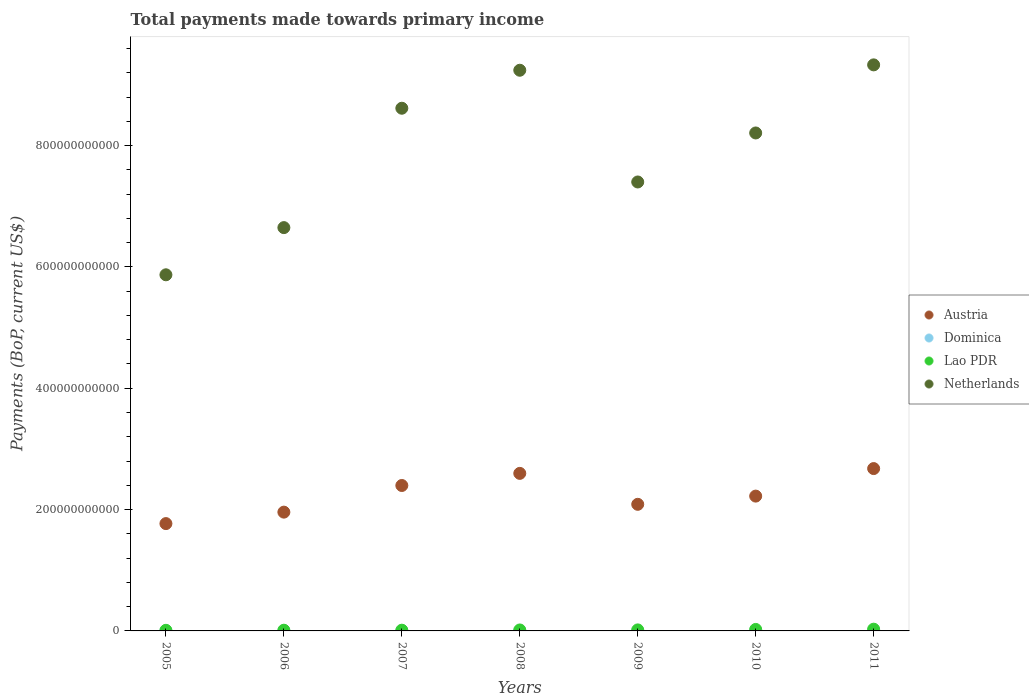How many different coloured dotlines are there?
Offer a very short reply. 4. Is the number of dotlines equal to the number of legend labels?
Make the answer very short. Yes. What is the total payments made towards primary income in Netherlands in 2009?
Your answer should be very brief. 7.40e+11. Across all years, what is the maximum total payments made towards primary income in Netherlands?
Make the answer very short. 9.33e+11. Across all years, what is the minimum total payments made towards primary income in Lao PDR?
Your answer should be very brief. 1.00e+09. In which year was the total payments made towards primary income in Lao PDR maximum?
Your response must be concise. 2011. In which year was the total payments made towards primary income in Lao PDR minimum?
Give a very brief answer. 2005. What is the total total payments made towards primary income in Lao PDR in the graph?
Keep it short and to the point. 1.20e+1. What is the difference between the total payments made towards primary income in Netherlands in 2005 and that in 2008?
Make the answer very short. -3.37e+11. What is the difference between the total payments made towards primary income in Netherlands in 2006 and the total payments made towards primary income in Dominica in 2009?
Your answer should be very brief. 6.65e+11. What is the average total payments made towards primary income in Dominica per year?
Your response must be concise. 2.68e+08. In the year 2011, what is the difference between the total payments made towards primary income in Austria and total payments made towards primary income in Lao PDR?
Keep it short and to the point. 2.65e+11. What is the ratio of the total payments made towards primary income in Dominica in 2009 to that in 2010?
Your answer should be very brief. 1.02. Is the total payments made towards primary income in Dominica in 2008 less than that in 2010?
Offer a very short reply. No. What is the difference between the highest and the second highest total payments made towards primary income in Austria?
Your answer should be very brief. 7.91e+09. What is the difference between the highest and the lowest total payments made towards primary income in Dominica?
Provide a short and direct response. 9.40e+07. Is the sum of the total payments made towards primary income in Lao PDR in 2006 and 2008 greater than the maximum total payments made towards primary income in Netherlands across all years?
Your response must be concise. No. Is it the case that in every year, the sum of the total payments made towards primary income in Netherlands and total payments made towards primary income in Austria  is greater than the sum of total payments made towards primary income in Lao PDR and total payments made towards primary income in Dominica?
Your response must be concise. Yes. Is it the case that in every year, the sum of the total payments made towards primary income in Netherlands and total payments made towards primary income in Austria  is greater than the total payments made towards primary income in Dominica?
Your answer should be very brief. Yes. Does the total payments made towards primary income in Austria monotonically increase over the years?
Your answer should be compact. No. How many dotlines are there?
Provide a short and direct response. 4. How many years are there in the graph?
Your answer should be compact. 7. What is the difference between two consecutive major ticks on the Y-axis?
Make the answer very short. 2.00e+11. Are the values on the major ticks of Y-axis written in scientific E-notation?
Make the answer very short. No. Where does the legend appear in the graph?
Your response must be concise. Center right. What is the title of the graph?
Your answer should be compact. Total payments made towards primary income. What is the label or title of the X-axis?
Offer a very short reply. Years. What is the label or title of the Y-axis?
Give a very brief answer. Payments (BoP, current US$). What is the Payments (BoP, current US$) of Austria in 2005?
Provide a succinct answer. 1.77e+11. What is the Payments (BoP, current US$) in Dominica in 2005?
Keep it short and to the point. 2.31e+08. What is the Payments (BoP, current US$) in Lao PDR in 2005?
Keep it short and to the point. 1.00e+09. What is the Payments (BoP, current US$) of Netherlands in 2005?
Provide a succinct answer. 5.87e+11. What is the Payments (BoP, current US$) of Austria in 2006?
Your answer should be very brief. 1.96e+11. What is the Payments (BoP, current US$) of Dominica in 2006?
Offer a terse response. 2.20e+08. What is the Payments (BoP, current US$) of Lao PDR in 2006?
Ensure brevity in your answer.  1.17e+09. What is the Payments (BoP, current US$) of Netherlands in 2006?
Ensure brevity in your answer.  6.65e+11. What is the Payments (BoP, current US$) of Austria in 2007?
Your answer should be compact. 2.40e+11. What is the Payments (BoP, current US$) in Dominica in 2007?
Your response must be concise. 2.64e+08. What is the Payments (BoP, current US$) in Lao PDR in 2007?
Make the answer very short. 1.20e+09. What is the Payments (BoP, current US$) in Netherlands in 2007?
Provide a short and direct response. 8.62e+11. What is the Payments (BoP, current US$) in Austria in 2008?
Ensure brevity in your answer.  2.60e+11. What is the Payments (BoP, current US$) in Dominica in 2008?
Your answer should be compact. 3.14e+08. What is the Payments (BoP, current US$) in Lao PDR in 2008?
Keep it short and to the point. 1.59e+09. What is the Payments (BoP, current US$) in Netherlands in 2008?
Your answer should be compact. 9.24e+11. What is the Payments (BoP, current US$) in Austria in 2009?
Your response must be concise. 2.09e+11. What is the Payments (BoP, current US$) of Dominica in 2009?
Offer a terse response. 2.85e+08. What is the Payments (BoP, current US$) in Lao PDR in 2009?
Make the answer very short. 1.69e+09. What is the Payments (BoP, current US$) of Netherlands in 2009?
Provide a succinct answer. 7.40e+11. What is the Payments (BoP, current US$) of Austria in 2010?
Make the answer very short. 2.22e+11. What is the Payments (BoP, current US$) in Dominica in 2010?
Offer a very short reply. 2.80e+08. What is the Payments (BoP, current US$) of Lao PDR in 2010?
Your response must be concise. 2.46e+09. What is the Payments (BoP, current US$) in Netherlands in 2010?
Your answer should be compact. 8.21e+11. What is the Payments (BoP, current US$) in Austria in 2011?
Your answer should be very brief. 2.68e+11. What is the Payments (BoP, current US$) of Dominica in 2011?
Make the answer very short. 2.80e+08. What is the Payments (BoP, current US$) in Lao PDR in 2011?
Offer a terse response. 2.88e+09. What is the Payments (BoP, current US$) in Netherlands in 2011?
Your answer should be very brief. 9.33e+11. Across all years, what is the maximum Payments (BoP, current US$) of Austria?
Keep it short and to the point. 2.68e+11. Across all years, what is the maximum Payments (BoP, current US$) of Dominica?
Offer a terse response. 3.14e+08. Across all years, what is the maximum Payments (BoP, current US$) of Lao PDR?
Ensure brevity in your answer.  2.88e+09. Across all years, what is the maximum Payments (BoP, current US$) of Netherlands?
Ensure brevity in your answer.  9.33e+11. Across all years, what is the minimum Payments (BoP, current US$) of Austria?
Give a very brief answer. 1.77e+11. Across all years, what is the minimum Payments (BoP, current US$) in Dominica?
Offer a terse response. 2.20e+08. Across all years, what is the minimum Payments (BoP, current US$) of Lao PDR?
Provide a short and direct response. 1.00e+09. Across all years, what is the minimum Payments (BoP, current US$) of Netherlands?
Offer a terse response. 5.87e+11. What is the total Payments (BoP, current US$) in Austria in the graph?
Give a very brief answer. 1.57e+12. What is the total Payments (BoP, current US$) in Dominica in the graph?
Your answer should be compact. 1.87e+09. What is the total Payments (BoP, current US$) of Lao PDR in the graph?
Give a very brief answer. 1.20e+1. What is the total Payments (BoP, current US$) of Netherlands in the graph?
Ensure brevity in your answer.  5.53e+12. What is the difference between the Payments (BoP, current US$) of Austria in 2005 and that in 2006?
Your answer should be very brief. -1.89e+1. What is the difference between the Payments (BoP, current US$) of Dominica in 2005 and that in 2006?
Ensure brevity in your answer.  1.10e+07. What is the difference between the Payments (BoP, current US$) in Lao PDR in 2005 and that in 2006?
Your response must be concise. -1.70e+08. What is the difference between the Payments (BoP, current US$) of Netherlands in 2005 and that in 2006?
Your answer should be compact. -7.78e+1. What is the difference between the Payments (BoP, current US$) of Austria in 2005 and that in 2007?
Make the answer very short. -6.28e+1. What is the difference between the Payments (BoP, current US$) in Dominica in 2005 and that in 2007?
Make the answer very short. -3.35e+07. What is the difference between the Payments (BoP, current US$) of Lao PDR in 2005 and that in 2007?
Provide a succinct answer. -1.99e+08. What is the difference between the Payments (BoP, current US$) in Netherlands in 2005 and that in 2007?
Provide a short and direct response. -2.75e+11. What is the difference between the Payments (BoP, current US$) in Austria in 2005 and that in 2008?
Offer a very short reply. -8.28e+1. What is the difference between the Payments (BoP, current US$) in Dominica in 2005 and that in 2008?
Your response must be concise. -8.30e+07. What is the difference between the Payments (BoP, current US$) in Lao PDR in 2005 and that in 2008?
Offer a terse response. -5.85e+08. What is the difference between the Payments (BoP, current US$) of Netherlands in 2005 and that in 2008?
Provide a succinct answer. -3.37e+11. What is the difference between the Payments (BoP, current US$) in Austria in 2005 and that in 2009?
Your answer should be very brief. -3.18e+1. What is the difference between the Payments (BoP, current US$) in Dominica in 2005 and that in 2009?
Offer a terse response. -5.37e+07. What is the difference between the Payments (BoP, current US$) in Lao PDR in 2005 and that in 2009?
Offer a very short reply. -6.82e+08. What is the difference between the Payments (BoP, current US$) of Netherlands in 2005 and that in 2009?
Ensure brevity in your answer.  -1.53e+11. What is the difference between the Payments (BoP, current US$) of Austria in 2005 and that in 2010?
Make the answer very short. -4.53e+1. What is the difference between the Payments (BoP, current US$) in Dominica in 2005 and that in 2010?
Ensure brevity in your answer.  -4.90e+07. What is the difference between the Payments (BoP, current US$) in Lao PDR in 2005 and that in 2010?
Your answer should be compact. -1.45e+09. What is the difference between the Payments (BoP, current US$) in Netherlands in 2005 and that in 2010?
Ensure brevity in your answer.  -2.34e+11. What is the difference between the Payments (BoP, current US$) in Austria in 2005 and that in 2011?
Provide a short and direct response. -9.07e+1. What is the difference between the Payments (BoP, current US$) in Dominica in 2005 and that in 2011?
Ensure brevity in your answer.  -4.93e+07. What is the difference between the Payments (BoP, current US$) in Lao PDR in 2005 and that in 2011?
Make the answer very short. -1.88e+09. What is the difference between the Payments (BoP, current US$) in Netherlands in 2005 and that in 2011?
Your response must be concise. -3.46e+11. What is the difference between the Payments (BoP, current US$) in Austria in 2006 and that in 2007?
Your answer should be very brief. -4.39e+1. What is the difference between the Payments (BoP, current US$) in Dominica in 2006 and that in 2007?
Give a very brief answer. -4.45e+07. What is the difference between the Payments (BoP, current US$) in Lao PDR in 2006 and that in 2007?
Provide a succinct answer. -2.94e+07. What is the difference between the Payments (BoP, current US$) of Netherlands in 2006 and that in 2007?
Provide a succinct answer. -1.97e+11. What is the difference between the Payments (BoP, current US$) in Austria in 2006 and that in 2008?
Offer a terse response. -6.39e+1. What is the difference between the Payments (BoP, current US$) in Dominica in 2006 and that in 2008?
Offer a terse response. -9.40e+07. What is the difference between the Payments (BoP, current US$) of Lao PDR in 2006 and that in 2008?
Offer a terse response. -4.16e+08. What is the difference between the Payments (BoP, current US$) in Netherlands in 2006 and that in 2008?
Offer a terse response. -2.59e+11. What is the difference between the Payments (BoP, current US$) of Austria in 2006 and that in 2009?
Your answer should be very brief. -1.29e+1. What is the difference between the Payments (BoP, current US$) of Dominica in 2006 and that in 2009?
Give a very brief answer. -6.47e+07. What is the difference between the Payments (BoP, current US$) of Lao PDR in 2006 and that in 2009?
Provide a short and direct response. -5.12e+08. What is the difference between the Payments (BoP, current US$) of Netherlands in 2006 and that in 2009?
Ensure brevity in your answer.  -7.52e+1. What is the difference between the Payments (BoP, current US$) in Austria in 2006 and that in 2010?
Offer a terse response. -2.64e+1. What is the difference between the Payments (BoP, current US$) in Dominica in 2006 and that in 2010?
Ensure brevity in your answer.  -6.00e+07. What is the difference between the Payments (BoP, current US$) of Lao PDR in 2006 and that in 2010?
Offer a very short reply. -1.28e+09. What is the difference between the Payments (BoP, current US$) in Netherlands in 2006 and that in 2010?
Ensure brevity in your answer.  -1.56e+11. What is the difference between the Payments (BoP, current US$) of Austria in 2006 and that in 2011?
Keep it short and to the point. -7.18e+1. What is the difference between the Payments (BoP, current US$) in Dominica in 2006 and that in 2011?
Offer a terse response. -6.03e+07. What is the difference between the Payments (BoP, current US$) in Lao PDR in 2006 and that in 2011?
Make the answer very short. -1.71e+09. What is the difference between the Payments (BoP, current US$) of Netherlands in 2006 and that in 2011?
Provide a short and direct response. -2.68e+11. What is the difference between the Payments (BoP, current US$) of Austria in 2007 and that in 2008?
Your answer should be very brief. -2.00e+1. What is the difference between the Payments (BoP, current US$) of Dominica in 2007 and that in 2008?
Keep it short and to the point. -4.96e+07. What is the difference between the Payments (BoP, current US$) in Lao PDR in 2007 and that in 2008?
Make the answer very short. -3.86e+08. What is the difference between the Payments (BoP, current US$) of Netherlands in 2007 and that in 2008?
Make the answer very short. -6.26e+1. What is the difference between the Payments (BoP, current US$) in Austria in 2007 and that in 2009?
Your answer should be compact. 3.10e+1. What is the difference between the Payments (BoP, current US$) of Dominica in 2007 and that in 2009?
Keep it short and to the point. -2.02e+07. What is the difference between the Payments (BoP, current US$) in Lao PDR in 2007 and that in 2009?
Your answer should be very brief. -4.83e+08. What is the difference between the Payments (BoP, current US$) of Netherlands in 2007 and that in 2009?
Provide a succinct answer. 1.22e+11. What is the difference between the Payments (BoP, current US$) of Austria in 2007 and that in 2010?
Your response must be concise. 1.75e+1. What is the difference between the Payments (BoP, current US$) in Dominica in 2007 and that in 2010?
Give a very brief answer. -1.56e+07. What is the difference between the Payments (BoP, current US$) in Lao PDR in 2007 and that in 2010?
Your answer should be very brief. -1.25e+09. What is the difference between the Payments (BoP, current US$) of Netherlands in 2007 and that in 2010?
Make the answer very short. 4.08e+1. What is the difference between the Payments (BoP, current US$) in Austria in 2007 and that in 2011?
Your answer should be compact. -2.79e+1. What is the difference between the Payments (BoP, current US$) in Dominica in 2007 and that in 2011?
Offer a terse response. -1.58e+07. What is the difference between the Payments (BoP, current US$) of Lao PDR in 2007 and that in 2011?
Ensure brevity in your answer.  -1.68e+09. What is the difference between the Payments (BoP, current US$) in Netherlands in 2007 and that in 2011?
Your answer should be compact. -7.15e+1. What is the difference between the Payments (BoP, current US$) of Austria in 2008 and that in 2009?
Provide a short and direct response. 5.10e+1. What is the difference between the Payments (BoP, current US$) of Dominica in 2008 and that in 2009?
Make the answer very short. 2.94e+07. What is the difference between the Payments (BoP, current US$) of Lao PDR in 2008 and that in 2009?
Provide a short and direct response. -9.67e+07. What is the difference between the Payments (BoP, current US$) in Netherlands in 2008 and that in 2009?
Provide a short and direct response. 1.84e+11. What is the difference between the Payments (BoP, current US$) of Austria in 2008 and that in 2010?
Ensure brevity in your answer.  3.75e+1. What is the difference between the Payments (BoP, current US$) in Dominica in 2008 and that in 2010?
Ensure brevity in your answer.  3.40e+07. What is the difference between the Payments (BoP, current US$) in Lao PDR in 2008 and that in 2010?
Your response must be concise. -8.68e+08. What is the difference between the Payments (BoP, current US$) of Netherlands in 2008 and that in 2010?
Your answer should be very brief. 1.03e+11. What is the difference between the Payments (BoP, current US$) of Austria in 2008 and that in 2011?
Your answer should be compact. -7.91e+09. What is the difference between the Payments (BoP, current US$) of Dominica in 2008 and that in 2011?
Offer a very short reply. 3.38e+07. What is the difference between the Payments (BoP, current US$) of Lao PDR in 2008 and that in 2011?
Your answer should be compact. -1.29e+09. What is the difference between the Payments (BoP, current US$) in Netherlands in 2008 and that in 2011?
Your answer should be very brief. -8.86e+09. What is the difference between the Payments (BoP, current US$) of Austria in 2009 and that in 2010?
Ensure brevity in your answer.  -1.35e+1. What is the difference between the Payments (BoP, current US$) of Dominica in 2009 and that in 2010?
Offer a terse response. 4.64e+06. What is the difference between the Payments (BoP, current US$) of Lao PDR in 2009 and that in 2010?
Offer a very short reply. -7.72e+08. What is the difference between the Payments (BoP, current US$) in Netherlands in 2009 and that in 2010?
Ensure brevity in your answer.  -8.08e+1. What is the difference between the Payments (BoP, current US$) in Austria in 2009 and that in 2011?
Provide a succinct answer. -5.89e+1. What is the difference between the Payments (BoP, current US$) of Dominica in 2009 and that in 2011?
Provide a short and direct response. 4.40e+06. What is the difference between the Payments (BoP, current US$) in Lao PDR in 2009 and that in 2011?
Your response must be concise. -1.20e+09. What is the difference between the Payments (BoP, current US$) of Netherlands in 2009 and that in 2011?
Offer a very short reply. -1.93e+11. What is the difference between the Payments (BoP, current US$) in Austria in 2010 and that in 2011?
Offer a very short reply. -4.54e+1. What is the difference between the Payments (BoP, current US$) in Dominica in 2010 and that in 2011?
Your response must be concise. -2.36e+05. What is the difference between the Payments (BoP, current US$) in Lao PDR in 2010 and that in 2011?
Offer a very short reply. -4.24e+08. What is the difference between the Payments (BoP, current US$) of Netherlands in 2010 and that in 2011?
Ensure brevity in your answer.  -1.12e+11. What is the difference between the Payments (BoP, current US$) in Austria in 2005 and the Payments (BoP, current US$) in Dominica in 2006?
Keep it short and to the point. 1.77e+11. What is the difference between the Payments (BoP, current US$) of Austria in 2005 and the Payments (BoP, current US$) of Lao PDR in 2006?
Offer a terse response. 1.76e+11. What is the difference between the Payments (BoP, current US$) of Austria in 2005 and the Payments (BoP, current US$) of Netherlands in 2006?
Offer a terse response. -4.88e+11. What is the difference between the Payments (BoP, current US$) in Dominica in 2005 and the Payments (BoP, current US$) in Lao PDR in 2006?
Your answer should be compact. -9.42e+08. What is the difference between the Payments (BoP, current US$) in Dominica in 2005 and the Payments (BoP, current US$) in Netherlands in 2006?
Offer a terse response. -6.65e+11. What is the difference between the Payments (BoP, current US$) of Lao PDR in 2005 and the Payments (BoP, current US$) of Netherlands in 2006?
Ensure brevity in your answer.  -6.64e+11. What is the difference between the Payments (BoP, current US$) of Austria in 2005 and the Payments (BoP, current US$) of Dominica in 2007?
Provide a short and direct response. 1.77e+11. What is the difference between the Payments (BoP, current US$) of Austria in 2005 and the Payments (BoP, current US$) of Lao PDR in 2007?
Make the answer very short. 1.76e+11. What is the difference between the Payments (BoP, current US$) of Austria in 2005 and the Payments (BoP, current US$) of Netherlands in 2007?
Your answer should be very brief. -6.85e+11. What is the difference between the Payments (BoP, current US$) of Dominica in 2005 and the Payments (BoP, current US$) of Lao PDR in 2007?
Your answer should be compact. -9.71e+08. What is the difference between the Payments (BoP, current US$) in Dominica in 2005 and the Payments (BoP, current US$) in Netherlands in 2007?
Keep it short and to the point. -8.61e+11. What is the difference between the Payments (BoP, current US$) of Lao PDR in 2005 and the Payments (BoP, current US$) of Netherlands in 2007?
Provide a short and direct response. -8.61e+11. What is the difference between the Payments (BoP, current US$) in Austria in 2005 and the Payments (BoP, current US$) in Dominica in 2008?
Your answer should be very brief. 1.77e+11. What is the difference between the Payments (BoP, current US$) of Austria in 2005 and the Payments (BoP, current US$) of Lao PDR in 2008?
Your response must be concise. 1.75e+11. What is the difference between the Payments (BoP, current US$) of Austria in 2005 and the Payments (BoP, current US$) of Netherlands in 2008?
Offer a very short reply. -7.47e+11. What is the difference between the Payments (BoP, current US$) of Dominica in 2005 and the Payments (BoP, current US$) of Lao PDR in 2008?
Provide a succinct answer. -1.36e+09. What is the difference between the Payments (BoP, current US$) in Dominica in 2005 and the Payments (BoP, current US$) in Netherlands in 2008?
Your answer should be very brief. -9.24e+11. What is the difference between the Payments (BoP, current US$) in Lao PDR in 2005 and the Payments (BoP, current US$) in Netherlands in 2008?
Ensure brevity in your answer.  -9.23e+11. What is the difference between the Payments (BoP, current US$) in Austria in 2005 and the Payments (BoP, current US$) in Dominica in 2009?
Offer a very short reply. 1.77e+11. What is the difference between the Payments (BoP, current US$) of Austria in 2005 and the Payments (BoP, current US$) of Lao PDR in 2009?
Offer a very short reply. 1.75e+11. What is the difference between the Payments (BoP, current US$) in Austria in 2005 and the Payments (BoP, current US$) in Netherlands in 2009?
Keep it short and to the point. -5.63e+11. What is the difference between the Payments (BoP, current US$) in Dominica in 2005 and the Payments (BoP, current US$) in Lao PDR in 2009?
Offer a very short reply. -1.45e+09. What is the difference between the Payments (BoP, current US$) of Dominica in 2005 and the Payments (BoP, current US$) of Netherlands in 2009?
Your answer should be compact. -7.40e+11. What is the difference between the Payments (BoP, current US$) of Lao PDR in 2005 and the Payments (BoP, current US$) of Netherlands in 2009?
Your answer should be very brief. -7.39e+11. What is the difference between the Payments (BoP, current US$) in Austria in 2005 and the Payments (BoP, current US$) in Dominica in 2010?
Keep it short and to the point. 1.77e+11. What is the difference between the Payments (BoP, current US$) in Austria in 2005 and the Payments (BoP, current US$) in Lao PDR in 2010?
Offer a very short reply. 1.74e+11. What is the difference between the Payments (BoP, current US$) in Austria in 2005 and the Payments (BoP, current US$) in Netherlands in 2010?
Ensure brevity in your answer.  -6.44e+11. What is the difference between the Payments (BoP, current US$) in Dominica in 2005 and the Payments (BoP, current US$) in Lao PDR in 2010?
Your answer should be compact. -2.23e+09. What is the difference between the Payments (BoP, current US$) in Dominica in 2005 and the Payments (BoP, current US$) in Netherlands in 2010?
Provide a succinct answer. -8.21e+11. What is the difference between the Payments (BoP, current US$) of Lao PDR in 2005 and the Payments (BoP, current US$) of Netherlands in 2010?
Make the answer very short. -8.20e+11. What is the difference between the Payments (BoP, current US$) in Austria in 2005 and the Payments (BoP, current US$) in Dominica in 2011?
Your answer should be compact. 1.77e+11. What is the difference between the Payments (BoP, current US$) of Austria in 2005 and the Payments (BoP, current US$) of Lao PDR in 2011?
Your answer should be compact. 1.74e+11. What is the difference between the Payments (BoP, current US$) in Austria in 2005 and the Payments (BoP, current US$) in Netherlands in 2011?
Provide a succinct answer. -7.56e+11. What is the difference between the Payments (BoP, current US$) in Dominica in 2005 and the Payments (BoP, current US$) in Lao PDR in 2011?
Offer a very short reply. -2.65e+09. What is the difference between the Payments (BoP, current US$) of Dominica in 2005 and the Payments (BoP, current US$) of Netherlands in 2011?
Offer a terse response. -9.33e+11. What is the difference between the Payments (BoP, current US$) of Lao PDR in 2005 and the Payments (BoP, current US$) of Netherlands in 2011?
Your response must be concise. -9.32e+11. What is the difference between the Payments (BoP, current US$) of Austria in 2006 and the Payments (BoP, current US$) of Dominica in 2007?
Provide a short and direct response. 1.96e+11. What is the difference between the Payments (BoP, current US$) of Austria in 2006 and the Payments (BoP, current US$) of Lao PDR in 2007?
Provide a succinct answer. 1.95e+11. What is the difference between the Payments (BoP, current US$) in Austria in 2006 and the Payments (BoP, current US$) in Netherlands in 2007?
Your response must be concise. -6.66e+11. What is the difference between the Payments (BoP, current US$) in Dominica in 2006 and the Payments (BoP, current US$) in Lao PDR in 2007?
Ensure brevity in your answer.  -9.82e+08. What is the difference between the Payments (BoP, current US$) in Dominica in 2006 and the Payments (BoP, current US$) in Netherlands in 2007?
Your answer should be compact. -8.61e+11. What is the difference between the Payments (BoP, current US$) in Lao PDR in 2006 and the Payments (BoP, current US$) in Netherlands in 2007?
Give a very brief answer. -8.60e+11. What is the difference between the Payments (BoP, current US$) of Austria in 2006 and the Payments (BoP, current US$) of Dominica in 2008?
Your answer should be compact. 1.95e+11. What is the difference between the Payments (BoP, current US$) of Austria in 2006 and the Payments (BoP, current US$) of Lao PDR in 2008?
Your answer should be very brief. 1.94e+11. What is the difference between the Payments (BoP, current US$) in Austria in 2006 and the Payments (BoP, current US$) in Netherlands in 2008?
Your answer should be very brief. -7.28e+11. What is the difference between the Payments (BoP, current US$) in Dominica in 2006 and the Payments (BoP, current US$) in Lao PDR in 2008?
Provide a succinct answer. -1.37e+09. What is the difference between the Payments (BoP, current US$) of Dominica in 2006 and the Payments (BoP, current US$) of Netherlands in 2008?
Your response must be concise. -9.24e+11. What is the difference between the Payments (BoP, current US$) in Lao PDR in 2006 and the Payments (BoP, current US$) in Netherlands in 2008?
Provide a succinct answer. -9.23e+11. What is the difference between the Payments (BoP, current US$) in Austria in 2006 and the Payments (BoP, current US$) in Dominica in 2009?
Make the answer very short. 1.96e+11. What is the difference between the Payments (BoP, current US$) of Austria in 2006 and the Payments (BoP, current US$) of Lao PDR in 2009?
Keep it short and to the point. 1.94e+11. What is the difference between the Payments (BoP, current US$) in Austria in 2006 and the Payments (BoP, current US$) in Netherlands in 2009?
Ensure brevity in your answer.  -5.44e+11. What is the difference between the Payments (BoP, current US$) of Dominica in 2006 and the Payments (BoP, current US$) of Lao PDR in 2009?
Make the answer very short. -1.47e+09. What is the difference between the Payments (BoP, current US$) in Dominica in 2006 and the Payments (BoP, current US$) in Netherlands in 2009?
Your answer should be very brief. -7.40e+11. What is the difference between the Payments (BoP, current US$) in Lao PDR in 2006 and the Payments (BoP, current US$) in Netherlands in 2009?
Your response must be concise. -7.39e+11. What is the difference between the Payments (BoP, current US$) of Austria in 2006 and the Payments (BoP, current US$) of Dominica in 2010?
Offer a very short reply. 1.96e+11. What is the difference between the Payments (BoP, current US$) in Austria in 2006 and the Payments (BoP, current US$) in Lao PDR in 2010?
Provide a succinct answer. 1.93e+11. What is the difference between the Payments (BoP, current US$) in Austria in 2006 and the Payments (BoP, current US$) in Netherlands in 2010?
Offer a very short reply. -6.25e+11. What is the difference between the Payments (BoP, current US$) of Dominica in 2006 and the Payments (BoP, current US$) of Lao PDR in 2010?
Ensure brevity in your answer.  -2.24e+09. What is the difference between the Payments (BoP, current US$) of Dominica in 2006 and the Payments (BoP, current US$) of Netherlands in 2010?
Offer a very short reply. -8.21e+11. What is the difference between the Payments (BoP, current US$) in Lao PDR in 2006 and the Payments (BoP, current US$) in Netherlands in 2010?
Your answer should be compact. -8.20e+11. What is the difference between the Payments (BoP, current US$) of Austria in 2006 and the Payments (BoP, current US$) of Dominica in 2011?
Give a very brief answer. 1.96e+11. What is the difference between the Payments (BoP, current US$) of Austria in 2006 and the Payments (BoP, current US$) of Lao PDR in 2011?
Keep it short and to the point. 1.93e+11. What is the difference between the Payments (BoP, current US$) in Austria in 2006 and the Payments (BoP, current US$) in Netherlands in 2011?
Give a very brief answer. -7.37e+11. What is the difference between the Payments (BoP, current US$) in Dominica in 2006 and the Payments (BoP, current US$) in Lao PDR in 2011?
Make the answer very short. -2.66e+09. What is the difference between the Payments (BoP, current US$) in Dominica in 2006 and the Payments (BoP, current US$) in Netherlands in 2011?
Your response must be concise. -9.33e+11. What is the difference between the Payments (BoP, current US$) in Lao PDR in 2006 and the Payments (BoP, current US$) in Netherlands in 2011?
Give a very brief answer. -9.32e+11. What is the difference between the Payments (BoP, current US$) of Austria in 2007 and the Payments (BoP, current US$) of Dominica in 2008?
Provide a short and direct response. 2.39e+11. What is the difference between the Payments (BoP, current US$) of Austria in 2007 and the Payments (BoP, current US$) of Lao PDR in 2008?
Provide a succinct answer. 2.38e+11. What is the difference between the Payments (BoP, current US$) of Austria in 2007 and the Payments (BoP, current US$) of Netherlands in 2008?
Provide a short and direct response. -6.84e+11. What is the difference between the Payments (BoP, current US$) in Dominica in 2007 and the Payments (BoP, current US$) in Lao PDR in 2008?
Ensure brevity in your answer.  -1.32e+09. What is the difference between the Payments (BoP, current US$) in Dominica in 2007 and the Payments (BoP, current US$) in Netherlands in 2008?
Your answer should be very brief. -9.24e+11. What is the difference between the Payments (BoP, current US$) of Lao PDR in 2007 and the Payments (BoP, current US$) of Netherlands in 2008?
Offer a very short reply. -9.23e+11. What is the difference between the Payments (BoP, current US$) in Austria in 2007 and the Payments (BoP, current US$) in Dominica in 2009?
Keep it short and to the point. 2.39e+11. What is the difference between the Payments (BoP, current US$) in Austria in 2007 and the Payments (BoP, current US$) in Lao PDR in 2009?
Keep it short and to the point. 2.38e+11. What is the difference between the Payments (BoP, current US$) of Austria in 2007 and the Payments (BoP, current US$) of Netherlands in 2009?
Your answer should be compact. -5.00e+11. What is the difference between the Payments (BoP, current US$) in Dominica in 2007 and the Payments (BoP, current US$) in Lao PDR in 2009?
Ensure brevity in your answer.  -1.42e+09. What is the difference between the Payments (BoP, current US$) in Dominica in 2007 and the Payments (BoP, current US$) in Netherlands in 2009?
Provide a short and direct response. -7.40e+11. What is the difference between the Payments (BoP, current US$) in Lao PDR in 2007 and the Payments (BoP, current US$) in Netherlands in 2009?
Offer a very short reply. -7.39e+11. What is the difference between the Payments (BoP, current US$) in Austria in 2007 and the Payments (BoP, current US$) in Dominica in 2010?
Give a very brief answer. 2.39e+11. What is the difference between the Payments (BoP, current US$) of Austria in 2007 and the Payments (BoP, current US$) of Lao PDR in 2010?
Provide a short and direct response. 2.37e+11. What is the difference between the Payments (BoP, current US$) of Austria in 2007 and the Payments (BoP, current US$) of Netherlands in 2010?
Keep it short and to the point. -5.81e+11. What is the difference between the Payments (BoP, current US$) in Dominica in 2007 and the Payments (BoP, current US$) in Lao PDR in 2010?
Your response must be concise. -2.19e+09. What is the difference between the Payments (BoP, current US$) of Dominica in 2007 and the Payments (BoP, current US$) of Netherlands in 2010?
Give a very brief answer. -8.21e+11. What is the difference between the Payments (BoP, current US$) of Lao PDR in 2007 and the Payments (BoP, current US$) of Netherlands in 2010?
Provide a short and direct response. -8.20e+11. What is the difference between the Payments (BoP, current US$) of Austria in 2007 and the Payments (BoP, current US$) of Dominica in 2011?
Offer a very short reply. 2.39e+11. What is the difference between the Payments (BoP, current US$) in Austria in 2007 and the Payments (BoP, current US$) in Lao PDR in 2011?
Your answer should be very brief. 2.37e+11. What is the difference between the Payments (BoP, current US$) of Austria in 2007 and the Payments (BoP, current US$) of Netherlands in 2011?
Make the answer very short. -6.93e+11. What is the difference between the Payments (BoP, current US$) in Dominica in 2007 and the Payments (BoP, current US$) in Lao PDR in 2011?
Ensure brevity in your answer.  -2.62e+09. What is the difference between the Payments (BoP, current US$) in Dominica in 2007 and the Payments (BoP, current US$) in Netherlands in 2011?
Offer a terse response. -9.33e+11. What is the difference between the Payments (BoP, current US$) in Lao PDR in 2007 and the Payments (BoP, current US$) in Netherlands in 2011?
Your response must be concise. -9.32e+11. What is the difference between the Payments (BoP, current US$) in Austria in 2008 and the Payments (BoP, current US$) in Dominica in 2009?
Provide a short and direct response. 2.59e+11. What is the difference between the Payments (BoP, current US$) in Austria in 2008 and the Payments (BoP, current US$) in Lao PDR in 2009?
Keep it short and to the point. 2.58e+11. What is the difference between the Payments (BoP, current US$) in Austria in 2008 and the Payments (BoP, current US$) in Netherlands in 2009?
Give a very brief answer. -4.80e+11. What is the difference between the Payments (BoP, current US$) in Dominica in 2008 and the Payments (BoP, current US$) in Lao PDR in 2009?
Your answer should be very brief. -1.37e+09. What is the difference between the Payments (BoP, current US$) in Dominica in 2008 and the Payments (BoP, current US$) in Netherlands in 2009?
Offer a terse response. -7.40e+11. What is the difference between the Payments (BoP, current US$) of Lao PDR in 2008 and the Payments (BoP, current US$) of Netherlands in 2009?
Make the answer very short. -7.38e+11. What is the difference between the Payments (BoP, current US$) in Austria in 2008 and the Payments (BoP, current US$) in Dominica in 2010?
Provide a short and direct response. 2.59e+11. What is the difference between the Payments (BoP, current US$) in Austria in 2008 and the Payments (BoP, current US$) in Lao PDR in 2010?
Your answer should be very brief. 2.57e+11. What is the difference between the Payments (BoP, current US$) of Austria in 2008 and the Payments (BoP, current US$) of Netherlands in 2010?
Ensure brevity in your answer.  -5.61e+11. What is the difference between the Payments (BoP, current US$) in Dominica in 2008 and the Payments (BoP, current US$) in Lao PDR in 2010?
Give a very brief answer. -2.14e+09. What is the difference between the Payments (BoP, current US$) of Dominica in 2008 and the Payments (BoP, current US$) of Netherlands in 2010?
Provide a succinct answer. -8.20e+11. What is the difference between the Payments (BoP, current US$) in Lao PDR in 2008 and the Payments (BoP, current US$) in Netherlands in 2010?
Your answer should be compact. -8.19e+11. What is the difference between the Payments (BoP, current US$) of Austria in 2008 and the Payments (BoP, current US$) of Dominica in 2011?
Keep it short and to the point. 2.59e+11. What is the difference between the Payments (BoP, current US$) of Austria in 2008 and the Payments (BoP, current US$) of Lao PDR in 2011?
Keep it short and to the point. 2.57e+11. What is the difference between the Payments (BoP, current US$) in Austria in 2008 and the Payments (BoP, current US$) in Netherlands in 2011?
Offer a very short reply. -6.73e+11. What is the difference between the Payments (BoP, current US$) in Dominica in 2008 and the Payments (BoP, current US$) in Lao PDR in 2011?
Your answer should be very brief. -2.57e+09. What is the difference between the Payments (BoP, current US$) of Dominica in 2008 and the Payments (BoP, current US$) of Netherlands in 2011?
Offer a terse response. -9.33e+11. What is the difference between the Payments (BoP, current US$) of Lao PDR in 2008 and the Payments (BoP, current US$) of Netherlands in 2011?
Make the answer very short. -9.31e+11. What is the difference between the Payments (BoP, current US$) in Austria in 2009 and the Payments (BoP, current US$) in Dominica in 2010?
Offer a terse response. 2.08e+11. What is the difference between the Payments (BoP, current US$) in Austria in 2009 and the Payments (BoP, current US$) in Lao PDR in 2010?
Keep it short and to the point. 2.06e+11. What is the difference between the Payments (BoP, current US$) of Austria in 2009 and the Payments (BoP, current US$) of Netherlands in 2010?
Offer a terse response. -6.12e+11. What is the difference between the Payments (BoP, current US$) of Dominica in 2009 and the Payments (BoP, current US$) of Lao PDR in 2010?
Provide a short and direct response. -2.17e+09. What is the difference between the Payments (BoP, current US$) in Dominica in 2009 and the Payments (BoP, current US$) in Netherlands in 2010?
Give a very brief answer. -8.21e+11. What is the difference between the Payments (BoP, current US$) of Lao PDR in 2009 and the Payments (BoP, current US$) of Netherlands in 2010?
Offer a very short reply. -8.19e+11. What is the difference between the Payments (BoP, current US$) of Austria in 2009 and the Payments (BoP, current US$) of Dominica in 2011?
Your answer should be compact. 2.08e+11. What is the difference between the Payments (BoP, current US$) of Austria in 2009 and the Payments (BoP, current US$) of Lao PDR in 2011?
Offer a terse response. 2.06e+11. What is the difference between the Payments (BoP, current US$) of Austria in 2009 and the Payments (BoP, current US$) of Netherlands in 2011?
Your answer should be very brief. -7.24e+11. What is the difference between the Payments (BoP, current US$) in Dominica in 2009 and the Payments (BoP, current US$) in Lao PDR in 2011?
Your response must be concise. -2.60e+09. What is the difference between the Payments (BoP, current US$) in Dominica in 2009 and the Payments (BoP, current US$) in Netherlands in 2011?
Offer a terse response. -9.33e+11. What is the difference between the Payments (BoP, current US$) of Lao PDR in 2009 and the Payments (BoP, current US$) of Netherlands in 2011?
Ensure brevity in your answer.  -9.31e+11. What is the difference between the Payments (BoP, current US$) of Austria in 2010 and the Payments (BoP, current US$) of Dominica in 2011?
Provide a succinct answer. 2.22e+11. What is the difference between the Payments (BoP, current US$) of Austria in 2010 and the Payments (BoP, current US$) of Lao PDR in 2011?
Provide a short and direct response. 2.19e+11. What is the difference between the Payments (BoP, current US$) in Austria in 2010 and the Payments (BoP, current US$) in Netherlands in 2011?
Your response must be concise. -7.11e+11. What is the difference between the Payments (BoP, current US$) in Dominica in 2010 and the Payments (BoP, current US$) in Lao PDR in 2011?
Give a very brief answer. -2.60e+09. What is the difference between the Payments (BoP, current US$) of Dominica in 2010 and the Payments (BoP, current US$) of Netherlands in 2011?
Your answer should be very brief. -9.33e+11. What is the difference between the Payments (BoP, current US$) of Lao PDR in 2010 and the Payments (BoP, current US$) of Netherlands in 2011?
Offer a terse response. -9.31e+11. What is the average Payments (BoP, current US$) of Austria per year?
Provide a succinct answer. 2.24e+11. What is the average Payments (BoP, current US$) in Dominica per year?
Make the answer very short. 2.68e+08. What is the average Payments (BoP, current US$) of Lao PDR per year?
Keep it short and to the point. 1.71e+09. What is the average Payments (BoP, current US$) in Netherlands per year?
Your answer should be compact. 7.90e+11. In the year 2005, what is the difference between the Payments (BoP, current US$) in Austria and Payments (BoP, current US$) in Dominica?
Give a very brief answer. 1.77e+11. In the year 2005, what is the difference between the Payments (BoP, current US$) of Austria and Payments (BoP, current US$) of Lao PDR?
Offer a very short reply. 1.76e+11. In the year 2005, what is the difference between the Payments (BoP, current US$) of Austria and Payments (BoP, current US$) of Netherlands?
Your response must be concise. -4.10e+11. In the year 2005, what is the difference between the Payments (BoP, current US$) in Dominica and Payments (BoP, current US$) in Lao PDR?
Your response must be concise. -7.72e+08. In the year 2005, what is the difference between the Payments (BoP, current US$) of Dominica and Payments (BoP, current US$) of Netherlands?
Your response must be concise. -5.87e+11. In the year 2005, what is the difference between the Payments (BoP, current US$) of Lao PDR and Payments (BoP, current US$) of Netherlands?
Keep it short and to the point. -5.86e+11. In the year 2006, what is the difference between the Payments (BoP, current US$) of Austria and Payments (BoP, current US$) of Dominica?
Ensure brevity in your answer.  1.96e+11. In the year 2006, what is the difference between the Payments (BoP, current US$) in Austria and Payments (BoP, current US$) in Lao PDR?
Keep it short and to the point. 1.95e+11. In the year 2006, what is the difference between the Payments (BoP, current US$) in Austria and Payments (BoP, current US$) in Netherlands?
Ensure brevity in your answer.  -4.69e+11. In the year 2006, what is the difference between the Payments (BoP, current US$) of Dominica and Payments (BoP, current US$) of Lao PDR?
Provide a short and direct response. -9.53e+08. In the year 2006, what is the difference between the Payments (BoP, current US$) of Dominica and Payments (BoP, current US$) of Netherlands?
Your response must be concise. -6.65e+11. In the year 2006, what is the difference between the Payments (BoP, current US$) of Lao PDR and Payments (BoP, current US$) of Netherlands?
Your response must be concise. -6.64e+11. In the year 2007, what is the difference between the Payments (BoP, current US$) in Austria and Payments (BoP, current US$) in Dominica?
Your answer should be very brief. 2.39e+11. In the year 2007, what is the difference between the Payments (BoP, current US$) of Austria and Payments (BoP, current US$) of Lao PDR?
Your answer should be very brief. 2.39e+11. In the year 2007, what is the difference between the Payments (BoP, current US$) of Austria and Payments (BoP, current US$) of Netherlands?
Offer a very short reply. -6.22e+11. In the year 2007, what is the difference between the Payments (BoP, current US$) of Dominica and Payments (BoP, current US$) of Lao PDR?
Provide a succinct answer. -9.38e+08. In the year 2007, what is the difference between the Payments (BoP, current US$) of Dominica and Payments (BoP, current US$) of Netherlands?
Give a very brief answer. -8.61e+11. In the year 2007, what is the difference between the Payments (BoP, current US$) of Lao PDR and Payments (BoP, current US$) of Netherlands?
Offer a very short reply. -8.60e+11. In the year 2008, what is the difference between the Payments (BoP, current US$) in Austria and Payments (BoP, current US$) in Dominica?
Keep it short and to the point. 2.59e+11. In the year 2008, what is the difference between the Payments (BoP, current US$) in Austria and Payments (BoP, current US$) in Lao PDR?
Ensure brevity in your answer.  2.58e+11. In the year 2008, what is the difference between the Payments (BoP, current US$) of Austria and Payments (BoP, current US$) of Netherlands?
Provide a succinct answer. -6.65e+11. In the year 2008, what is the difference between the Payments (BoP, current US$) of Dominica and Payments (BoP, current US$) of Lao PDR?
Offer a terse response. -1.27e+09. In the year 2008, what is the difference between the Payments (BoP, current US$) in Dominica and Payments (BoP, current US$) in Netherlands?
Your answer should be very brief. -9.24e+11. In the year 2008, what is the difference between the Payments (BoP, current US$) in Lao PDR and Payments (BoP, current US$) in Netherlands?
Offer a very short reply. -9.23e+11. In the year 2009, what is the difference between the Payments (BoP, current US$) in Austria and Payments (BoP, current US$) in Dominica?
Your response must be concise. 2.08e+11. In the year 2009, what is the difference between the Payments (BoP, current US$) of Austria and Payments (BoP, current US$) of Lao PDR?
Your answer should be very brief. 2.07e+11. In the year 2009, what is the difference between the Payments (BoP, current US$) in Austria and Payments (BoP, current US$) in Netherlands?
Make the answer very short. -5.31e+11. In the year 2009, what is the difference between the Payments (BoP, current US$) in Dominica and Payments (BoP, current US$) in Lao PDR?
Your answer should be compact. -1.40e+09. In the year 2009, what is the difference between the Payments (BoP, current US$) of Dominica and Payments (BoP, current US$) of Netherlands?
Your response must be concise. -7.40e+11. In the year 2009, what is the difference between the Payments (BoP, current US$) in Lao PDR and Payments (BoP, current US$) in Netherlands?
Keep it short and to the point. -7.38e+11. In the year 2010, what is the difference between the Payments (BoP, current US$) of Austria and Payments (BoP, current US$) of Dominica?
Keep it short and to the point. 2.22e+11. In the year 2010, what is the difference between the Payments (BoP, current US$) of Austria and Payments (BoP, current US$) of Lao PDR?
Ensure brevity in your answer.  2.20e+11. In the year 2010, what is the difference between the Payments (BoP, current US$) of Austria and Payments (BoP, current US$) of Netherlands?
Offer a very short reply. -5.99e+11. In the year 2010, what is the difference between the Payments (BoP, current US$) of Dominica and Payments (BoP, current US$) of Lao PDR?
Provide a succinct answer. -2.18e+09. In the year 2010, what is the difference between the Payments (BoP, current US$) of Dominica and Payments (BoP, current US$) of Netherlands?
Your answer should be compact. -8.21e+11. In the year 2010, what is the difference between the Payments (BoP, current US$) of Lao PDR and Payments (BoP, current US$) of Netherlands?
Provide a succinct answer. -8.18e+11. In the year 2011, what is the difference between the Payments (BoP, current US$) in Austria and Payments (BoP, current US$) in Dominica?
Your answer should be compact. 2.67e+11. In the year 2011, what is the difference between the Payments (BoP, current US$) of Austria and Payments (BoP, current US$) of Lao PDR?
Your answer should be very brief. 2.65e+11. In the year 2011, what is the difference between the Payments (BoP, current US$) of Austria and Payments (BoP, current US$) of Netherlands?
Give a very brief answer. -6.65e+11. In the year 2011, what is the difference between the Payments (BoP, current US$) in Dominica and Payments (BoP, current US$) in Lao PDR?
Give a very brief answer. -2.60e+09. In the year 2011, what is the difference between the Payments (BoP, current US$) of Dominica and Payments (BoP, current US$) of Netherlands?
Offer a very short reply. -9.33e+11. In the year 2011, what is the difference between the Payments (BoP, current US$) in Lao PDR and Payments (BoP, current US$) in Netherlands?
Your answer should be compact. -9.30e+11. What is the ratio of the Payments (BoP, current US$) of Austria in 2005 to that in 2006?
Your response must be concise. 0.9. What is the ratio of the Payments (BoP, current US$) in Dominica in 2005 to that in 2006?
Your response must be concise. 1.05. What is the ratio of the Payments (BoP, current US$) in Lao PDR in 2005 to that in 2006?
Provide a short and direct response. 0.86. What is the ratio of the Payments (BoP, current US$) of Netherlands in 2005 to that in 2006?
Keep it short and to the point. 0.88. What is the ratio of the Payments (BoP, current US$) of Austria in 2005 to that in 2007?
Provide a succinct answer. 0.74. What is the ratio of the Payments (BoP, current US$) in Dominica in 2005 to that in 2007?
Your response must be concise. 0.87. What is the ratio of the Payments (BoP, current US$) in Lao PDR in 2005 to that in 2007?
Your response must be concise. 0.83. What is the ratio of the Payments (BoP, current US$) in Netherlands in 2005 to that in 2007?
Provide a succinct answer. 0.68. What is the ratio of the Payments (BoP, current US$) of Austria in 2005 to that in 2008?
Offer a very short reply. 0.68. What is the ratio of the Payments (BoP, current US$) of Dominica in 2005 to that in 2008?
Ensure brevity in your answer.  0.74. What is the ratio of the Payments (BoP, current US$) of Lao PDR in 2005 to that in 2008?
Offer a terse response. 0.63. What is the ratio of the Payments (BoP, current US$) in Netherlands in 2005 to that in 2008?
Offer a terse response. 0.64. What is the ratio of the Payments (BoP, current US$) in Austria in 2005 to that in 2009?
Your answer should be very brief. 0.85. What is the ratio of the Payments (BoP, current US$) in Dominica in 2005 to that in 2009?
Your answer should be very brief. 0.81. What is the ratio of the Payments (BoP, current US$) in Lao PDR in 2005 to that in 2009?
Provide a succinct answer. 0.6. What is the ratio of the Payments (BoP, current US$) in Netherlands in 2005 to that in 2009?
Make the answer very short. 0.79. What is the ratio of the Payments (BoP, current US$) in Austria in 2005 to that in 2010?
Make the answer very short. 0.8. What is the ratio of the Payments (BoP, current US$) in Dominica in 2005 to that in 2010?
Provide a succinct answer. 0.82. What is the ratio of the Payments (BoP, current US$) in Lao PDR in 2005 to that in 2010?
Ensure brevity in your answer.  0.41. What is the ratio of the Payments (BoP, current US$) in Netherlands in 2005 to that in 2010?
Provide a succinct answer. 0.72. What is the ratio of the Payments (BoP, current US$) of Austria in 2005 to that in 2011?
Your answer should be very brief. 0.66. What is the ratio of the Payments (BoP, current US$) of Dominica in 2005 to that in 2011?
Provide a short and direct response. 0.82. What is the ratio of the Payments (BoP, current US$) in Lao PDR in 2005 to that in 2011?
Your answer should be compact. 0.35. What is the ratio of the Payments (BoP, current US$) in Netherlands in 2005 to that in 2011?
Offer a terse response. 0.63. What is the ratio of the Payments (BoP, current US$) of Austria in 2006 to that in 2007?
Keep it short and to the point. 0.82. What is the ratio of the Payments (BoP, current US$) in Dominica in 2006 to that in 2007?
Your answer should be compact. 0.83. What is the ratio of the Payments (BoP, current US$) of Lao PDR in 2006 to that in 2007?
Provide a succinct answer. 0.98. What is the ratio of the Payments (BoP, current US$) in Netherlands in 2006 to that in 2007?
Your answer should be very brief. 0.77. What is the ratio of the Payments (BoP, current US$) of Austria in 2006 to that in 2008?
Make the answer very short. 0.75. What is the ratio of the Payments (BoP, current US$) of Dominica in 2006 to that in 2008?
Your answer should be very brief. 0.7. What is the ratio of the Payments (BoP, current US$) of Lao PDR in 2006 to that in 2008?
Make the answer very short. 0.74. What is the ratio of the Payments (BoP, current US$) in Netherlands in 2006 to that in 2008?
Keep it short and to the point. 0.72. What is the ratio of the Payments (BoP, current US$) in Austria in 2006 to that in 2009?
Keep it short and to the point. 0.94. What is the ratio of the Payments (BoP, current US$) of Dominica in 2006 to that in 2009?
Offer a very short reply. 0.77. What is the ratio of the Payments (BoP, current US$) in Lao PDR in 2006 to that in 2009?
Keep it short and to the point. 0.7. What is the ratio of the Payments (BoP, current US$) in Netherlands in 2006 to that in 2009?
Ensure brevity in your answer.  0.9. What is the ratio of the Payments (BoP, current US$) in Austria in 2006 to that in 2010?
Offer a very short reply. 0.88. What is the ratio of the Payments (BoP, current US$) in Dominica in 2006 to that in 2010?
Make the answer very short. 0.79. What is the ratio of the Payments (BoP, current US$) in Lao PDR in 2006 to that in 2010?
Your response must be concise. 0.48. What is the ratio of the Payments (BoP, current US$) in Netherlands in 2006 to that in 2010?
Your response must be concise. 0.81. What is the ratio of the Payments (BoP, current US$) of Austria in 2006 to that in 2011?
Keep it short and to the point. 0.73. What is the ratio of the Payments (BoP, current US$) of Dominica in 2006 to that in 2011?
Make the answer very short. 0.79. What is the ratio of the Payments (BoP, current US$) of Lao PDR in 2006 to that in 2011?
Give a very brief answer. 0.41. What is the ratio of the Payments (BoP, current US$) in Netherlands in 2006 to that in 2011?
Ensure brevity in your answer.  0.71. What is the ratio of the Payments (BoP, current US$) of Dominica in 2007 to that in 2008?
Offer a very short reply. 0.84. What is the ratio of the Payments (BoP, current US$) in Lao PDR in 2007 to that in 2008?
Provide a succinct answer. 0.76. What is the ratio of the Payments (BoP, current US$) of Netherlands in 2007 to that in 2008?
Your answer should be very brief. 0.93. What is the ratio of the Payments (BoP, current US$) in Austria in 2007 to that in 2009?
Give a very brief answer. 1.15. What is the ratio of the Payments (BoP, current US$) in Dominica in 2007 to that in 2009?
Ensure brevity in your answer.  0.93. What is the ratio of the Payments (BoP, current US$) of Lao PDR in 2007 to that in 2009?
Offer a very short reply. 0.71. What is the ratio of the Payments (BoP, current US$) of Netherlands in 2007 to that in 2009?
Make the answer very short. 1.16. What is the ratio of the Payments (BoP, current US$) in Austria in 2007 to that in 2010?
Your answer should be compact. 1.08. What is the ratio of the Payments (BoP, current US$) in Lao PDR in 2007 to that in 2010?
Offer a terse response. 0.49. What is the ratio of the Payments (BoP, current US$) of Netherlands in 2007 to that in 2010?
Offer a very short reply. 1.05. What is the ratio of the Payments (BoP, current US$) of Austria in 2007 to that in 2011?
Your answer should be compact. 0.9. What is the ratio of the Payments (BoP, current US$) in Dominica in 2007 to that in 2011?
Give a very brief answer. 0.94. What is the ratio of the Payments (BoP, current US$) in Lao PDR in 2007 to that in 2011?
Offer a very short reply. 0.42. What is the ratio of the Payments (BoP, current US$) in Netherlands in 2007 to that in 2011?
Offer a terse response. 0.92. What is the ratio of the Payments (BoP, current US$) of Austria in 2008 to that in 2009?
Provide a short and direct response. 1.24. What is the ratio of the Payments (BoP, current US$) in Dominica in 2008 to that in 2009?
Keep it short and to the point. 1.1. What is the ratio of the Payments (BoP, current US$) of Lao PDR in 2008 to that in 2009?
Your answer should be compact. 0.94. What is the ratio of the Payments (BoP, current US$) in Netherlands in 2008 to that in 2009?
Your answer should be compact. 1.25. What is the ratio of the Payments (BoP, current US$) of Austria in 2008 to that in 2010?
Provide a short and direct response. 1.17. What is the ratio of the Payments (BoP, current US$) in Dominica in 2008 to that in 2010?
Give a very brief answer. 1.12. What is the ratio of the Payments (BoP, current US$) in Lao PDR in 2008 to that in 2010?
Your answer should be compact. 0.65. What is the ratio of the Payments (BoP, current US$) of Netherlands in 2008 to that in 2010?
Your response must be concise. 1.13. What is the ratio of the Payments (BoP, current US$) of Austria in 2008 to that in 2011?
Your answer should be compact. 0.97. What is the ratio of the Payments (BoP, current US$) in Dominica in 2008 to that in 2011?
Give a very brief answer. 1.12. What is the ratio of the Payments (BoP, current US$) of Lao PDR in 2008 to that in 2011?
Offer a very short reply. 0.55. What is the ratio of the Payments (BoP, current US$) of Austria in 2009 to that in 2010?
Ensure brevity in your answer.  0.94. What is the ratio of the Payments (BoP, current US$) of Dominica in 2009 to that in 2010?
Ensure brevity in your answer.  1.02. What is the ratio of the Payments (BoP, current US$) in Lao PDR in 2009 to that in 2010?
Your answer should be very brief. 0.69. What is the ratio of the Payments (BoP, current US$) of Netherlands in 2009 to that in 2010?
Offer a terse response. 0.9. What is the ratio of the Payments (BoP, current US$) of Austria in 2009 to that in 2011?
Keep it short and to the point. 0.78. What is the ratio of the Payments (BoP, current US$) in Dominica in 2009 to that in 2011?
Provide a short and direct response. 1.02. What is the ratio of the Payments (BoP, current US$) of Lao PDR in 2009 to that in 2011?
Ensure brevity in your answer.  0.58. What is the ratio of the Payments (BoP, current US$) of Netherlands in 2009 to that in 2011?
Your answer should be compact. 0.79. What is the ratio of the Payments (BoP, current US$) of Austria in 2010 to that in 2011?
Your answer should be very brief. 0.83. What is the ratio of the Payments (BoP, current US$) in Lao PDR in 2010 to that in 2011?
Give a very brief answer. 0.85. What is the ratio of the Payments (BoP, current US$) in Netherlands in 2010 to that in 2011?
Ensure brevity in your answer.  0.88. What is the difference between the highest and the second highest Payments (BoP, current US$) in Austria?
Ensure brevity in your answer.  7.91e+09. What is the difference between the highest and the second highest Payments (BoP, current US$) in Dominica?
Your answer should be very brief. 2.94e+07. What is the difference between the highest and the second highest Payments (BoP, current US$) of Lao PDR?
Your answer should be compact. 4.24e+08. What is the difference between the highest and the second highest Payments (BoP, current US$) of Netherlands?
Give a very brief answer. 8.86e+09. What is the difference between the highest and the lowest Payments (BoP, current US$) of Austria?
Your answer should be very brief. 9.07e+1. What is the difference between the highest and the lowest Payments (BoP, current US$) in Dominica?
Give a very brief answer. 9.40e+07. What is the difference between the highest and the lowest Payments (BoP, current US$) in Lao PDR?
Make the answer very short. 1.88e+09. What is the difference between the highest and the lowest Payments (BoP, current US$) in Netherlands?
Your response must be concise. 3.46e+11. 